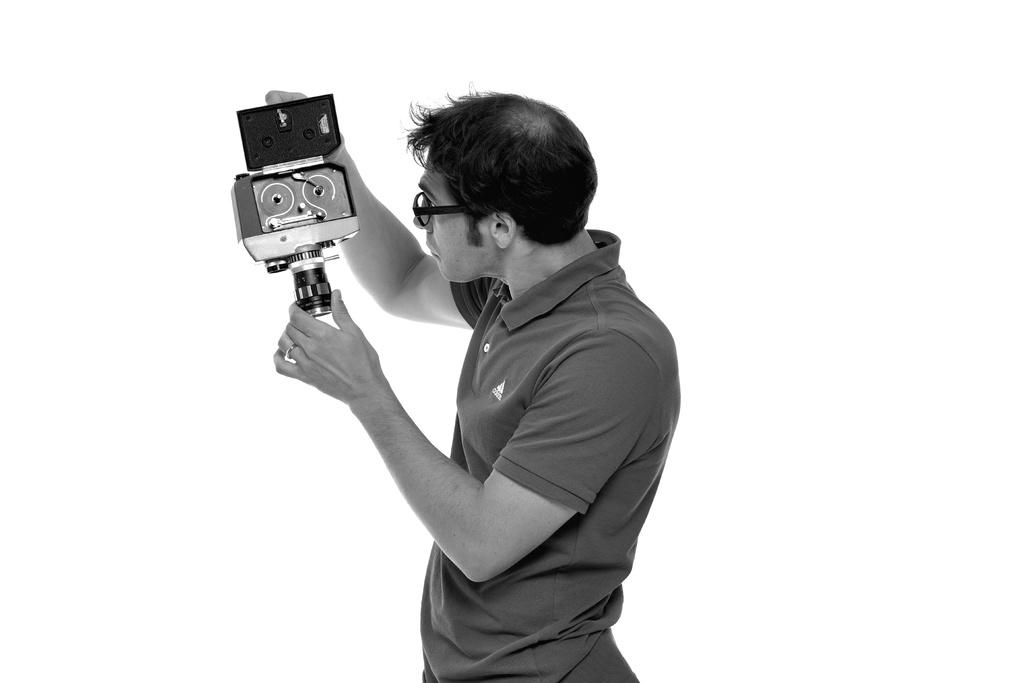What is present in the image? There is a person in the image. What is the person holding in their hands? The person is holding something in their hands. How is the person interacting with the object they are holding? The person is looking at the object they are holding. How many ducks are visible in the image? There are no ducks present in the image. What type of books is the person reading in the image? There is no indication in the image that the person is reading a book, as the facts provided do not mention any books. --- Facts: 1. There is a person in the image. 2. The person is wearing a hat. 3. The person is holding a cup. 4. The cup is filled with a beverage. 5. The background of the image is a park. Absurd Topics: elephant, bicycle, ocean Conversation: What is present in the image? There is a person in the image. What is the person wearing on their head? The person is wearing a hat. What is the person holding in their hands? The person is holding a cup. What is in the cup that the person is holding? The cup is filled with a beverage. What is the setting of the image? The background of the image is a park. Reasoning: Let's think step by step in order to produce the conversation. We start by identifying the main subject in the image, which is the person. Then, we expand the conversation to include the person's attire (the hat), the object they are holding (the cup), the contents of the cup (the beverage), and the setting of the image (the park). Each question is designed to elicit a specific detail about the image that is known from the provided facts. Absurd Question/Answer: How many elephants can be seen in the park in the image? There are no elephants present in the image. What type of bicycle is the person riding in the image? There is no bicycle present in the image. Can you see the ocean in the background of the image? The background of the image is a park, not the ocean. --- Facts: 1. There is a person in the image. 2. The person is holding a camera. 3. The person is standing near a tree. 4. The tree has green leaves. 5. The sky is visible in the image. Absurd Topics: parrot, umbrella, volcano Conversation: What is present in the image? There is a person in the image. What is the person holding in their hands? The person is holding a camera. Where is the person standing in relation to the tree? The person is standing near a tree. What is the condition of the tree's leaves? The 